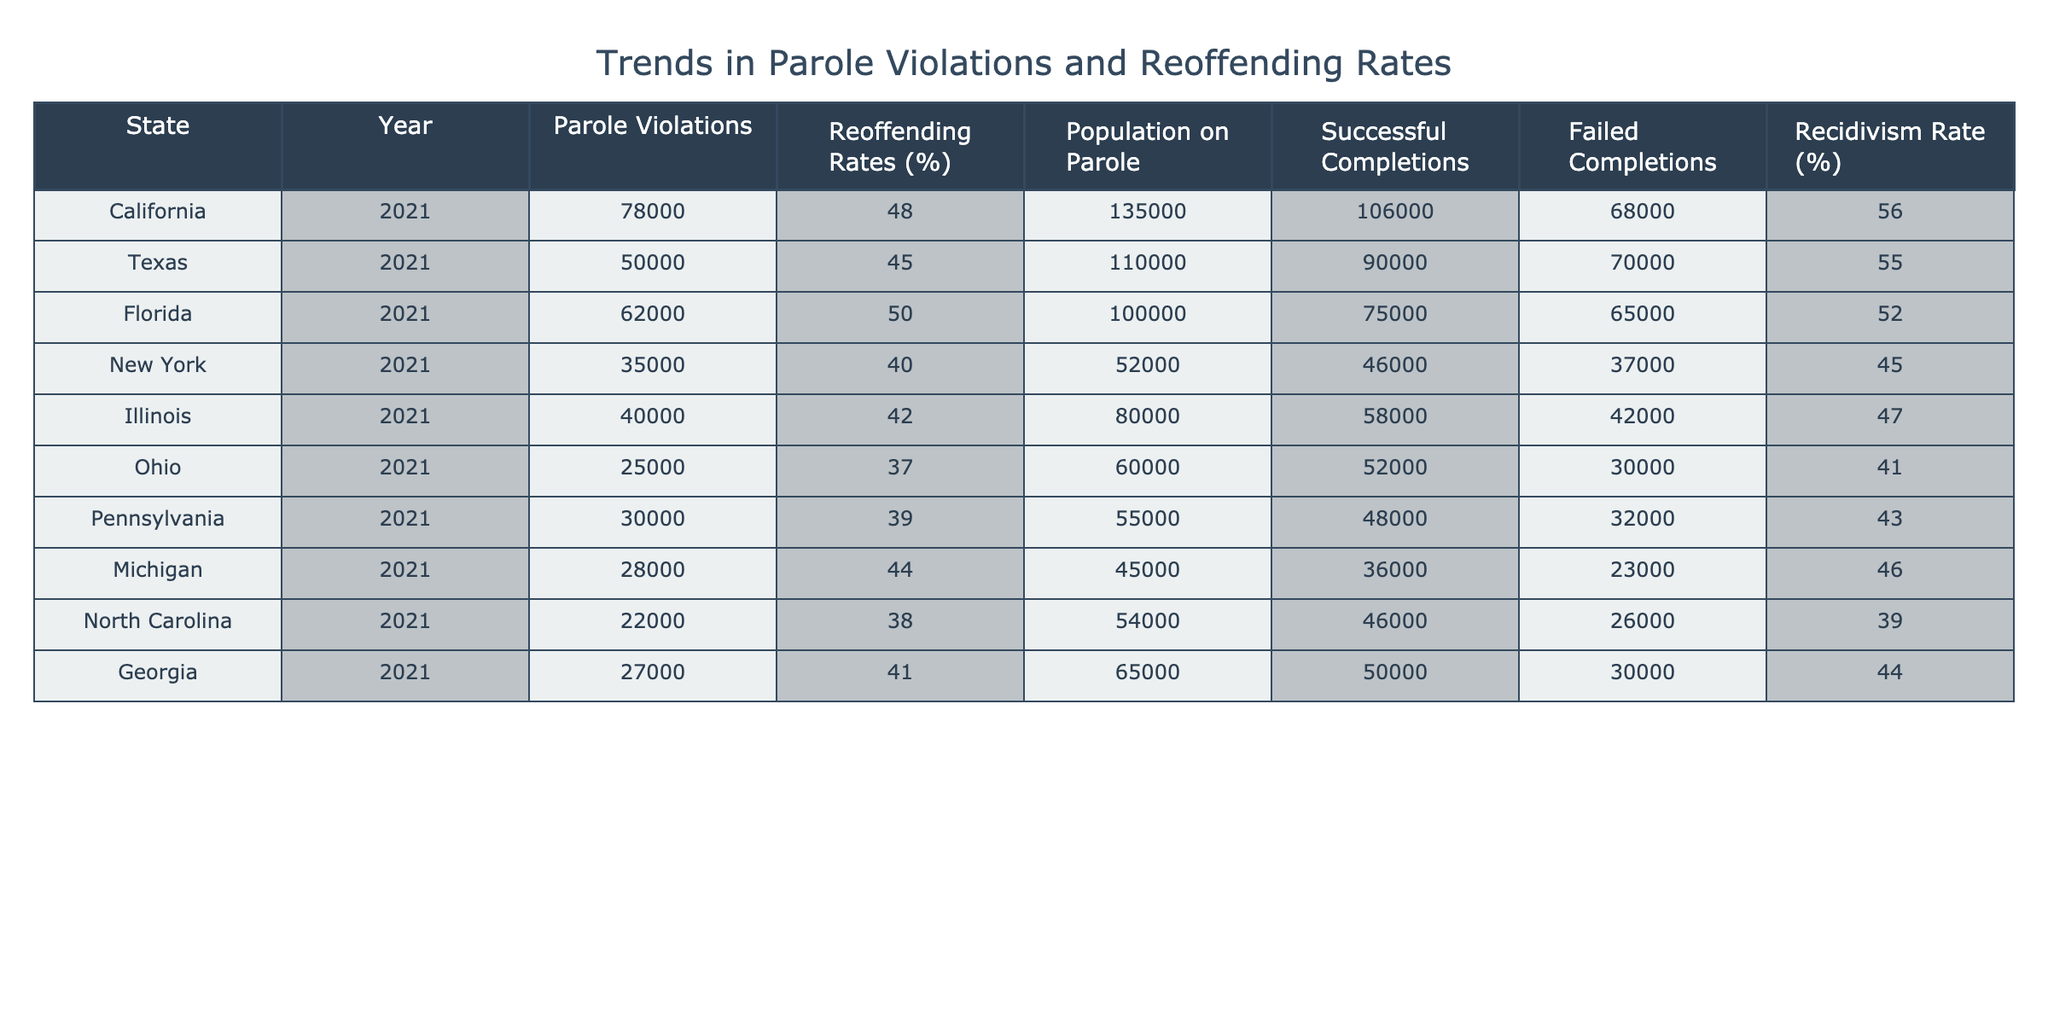What is the state with the highest number of parole violations? From the table, California has 78,000 parole violations, which is higher than any other state listed.
Answer: California Which state has the lowest reoffending rate? Ohio has the lowest reoffending rate at 37%, as indicated in the table.
Answer: Ohio What is the total number of successful completions for all states combined? To find the total successful completions, sum the values from the Successful Completions column: 106000 + 90000 + 75000 + 46000 + 58000 + 52000 + 48000 + 36000 + 46000 + 50000 =  533000.
Answer: 533000 Is the recidivism rate of Texas higher than that of Florida? Texas has a recidivism rate of 55%, while Florida's is 52%. Since 55% is greater than 52%, the statement is true.
Answer: Yes What is the average number of parole violations across all states? To calculate the average, sum all the parole violations: 78000 + 50000 + 62000 + 35000 + 40000 + 25000 + 30000 + 28000 + 22000 + 27000 =  397000. Then divide by the number of states (10): 397000 / 10 = 39700.
Answer: 39700 Which state has the most failed completions? From the table, California has the most failed completions with 68,000, which is more than any other state.
Answer: California Is it true that New York has more parole violations than North Carolina? Yes, New York has 35,000 parole violations, while North Carolina has only 22,000, making the statement true.
Answer: Yes What is the difference in reoffending rates between California and Ohio? California has a reoffending rate of 48% and Ohio has 37%. The difference is 48% - 37% = 11%.
Answer: 11% What percentage of the population on parole in Florida successfully completed their parole? In Florida, there were 100,000 people on parole and 75,000 successful completions. The percentage is (75000 / 100000) * 100 = 75%.
Answer: 75% 